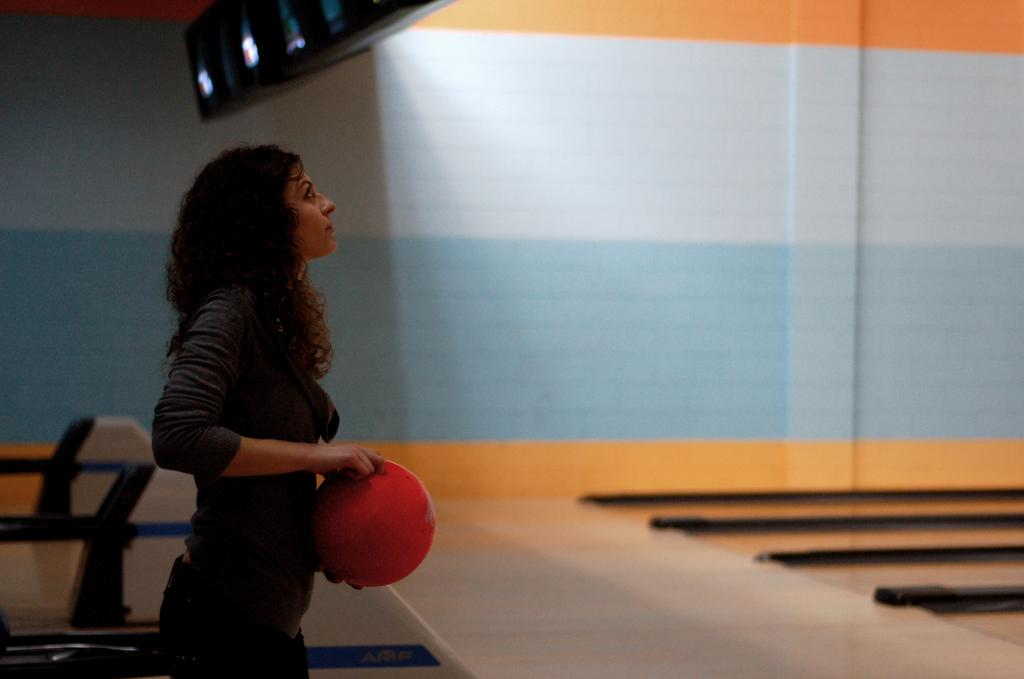Who is the main subject in the image? There is a lady in the image. What is the lady doing in the image? The lady is standing in the image. What is the lady holding in the image? The lady is holding a ball in the image. What is the color of the ball? The ball is red in color. What can be seen in the background of the image? There is a wall in the background of the image. What type of quartz can be seen on the lady's clothing in the image? There is no quartz visible on the lady's clothing in the image. What action is the lady performing with the ball in the image? The provided facts do not specify any action the lady is performing with the ball; she is simply holding it. 